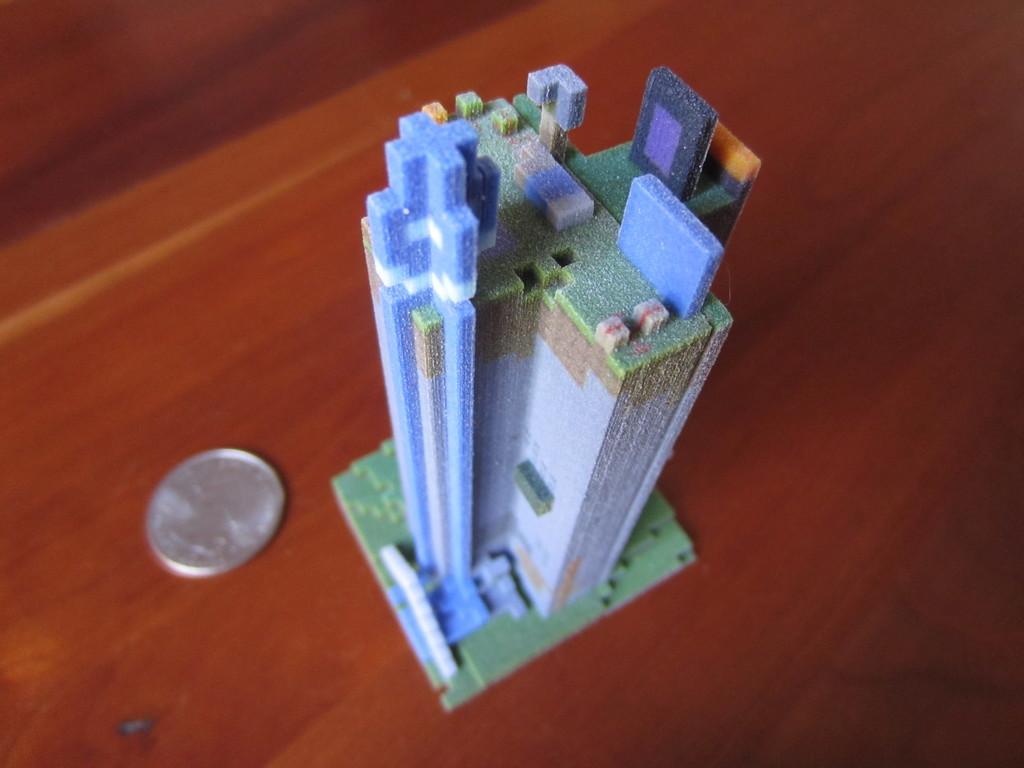In one or two sentences, can you explain what this image depicts? In the center of the picture there is a duplicate of a building, beside the building there is a coin. At the bottom it is table. 